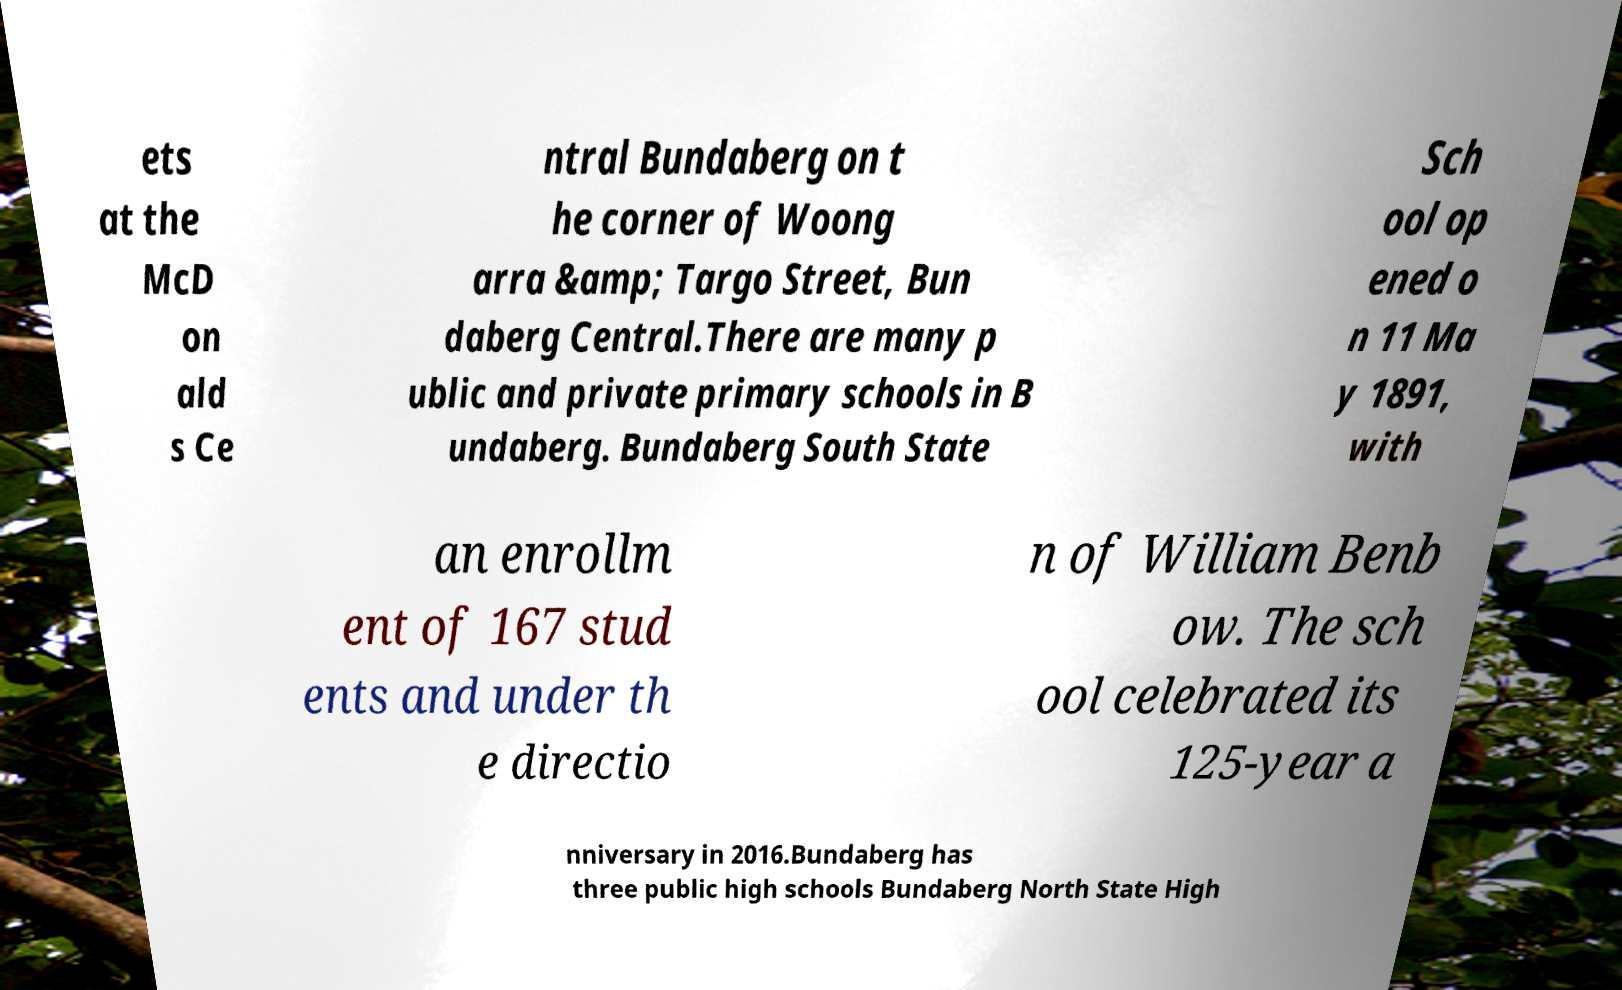Could you assist in decoding the text presented in this image and type it out clearly? ets at the McD on ald s Ce ntral Bundaberg on t he corner of Woong arra &amp; Targo Street, Bun daberg Central.There are many p ublic and private primary schools in B undaberg. Bundaberg South State Sch ool op ened o n 11 Ma y 1891, with an enrollm ent of 167 stud ents and under th e directio n of William Benb ow. The sch ool celebrated its 125-year a nniversary in 2016.Bundaberg has three public high schools Bundaberg North State High 